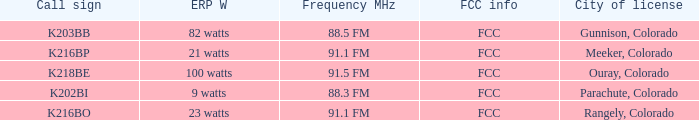Which FCC info has an ERP W of 100 watts? FCC. 